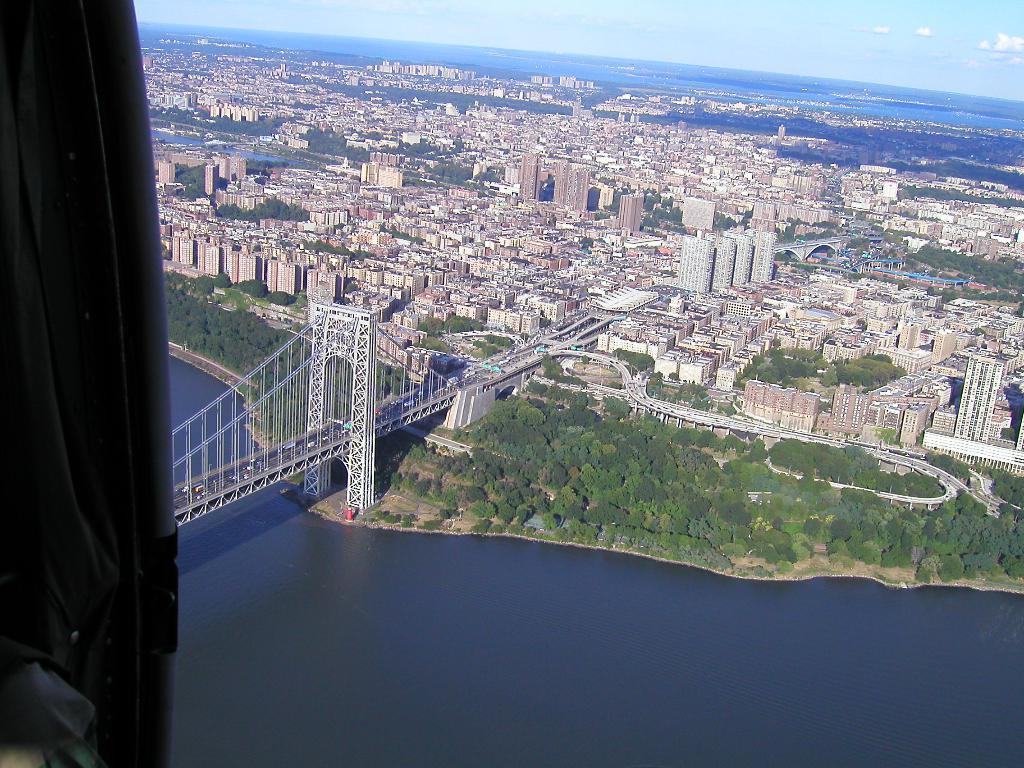In one or two sentences, can you explain what this image depicts? This is a top view of an airplane view of a city. Where I can see buildings, roads and bridges, trees and rivers.  